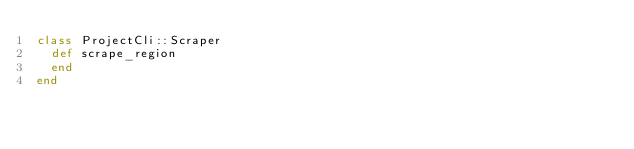<code> <loc_0><loc_0><loc_500><loc_500><_Ruby_>class ProjectCli::Scraper
  def scrape_region
  end
end
</code> 